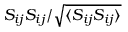<formula> <loc_0><loc_0><loc_500><loc_500>S _ { i j } S _ { i j } / \sqrt { \langle S _ { i j } S _ { i j } \rangle }</formula> 